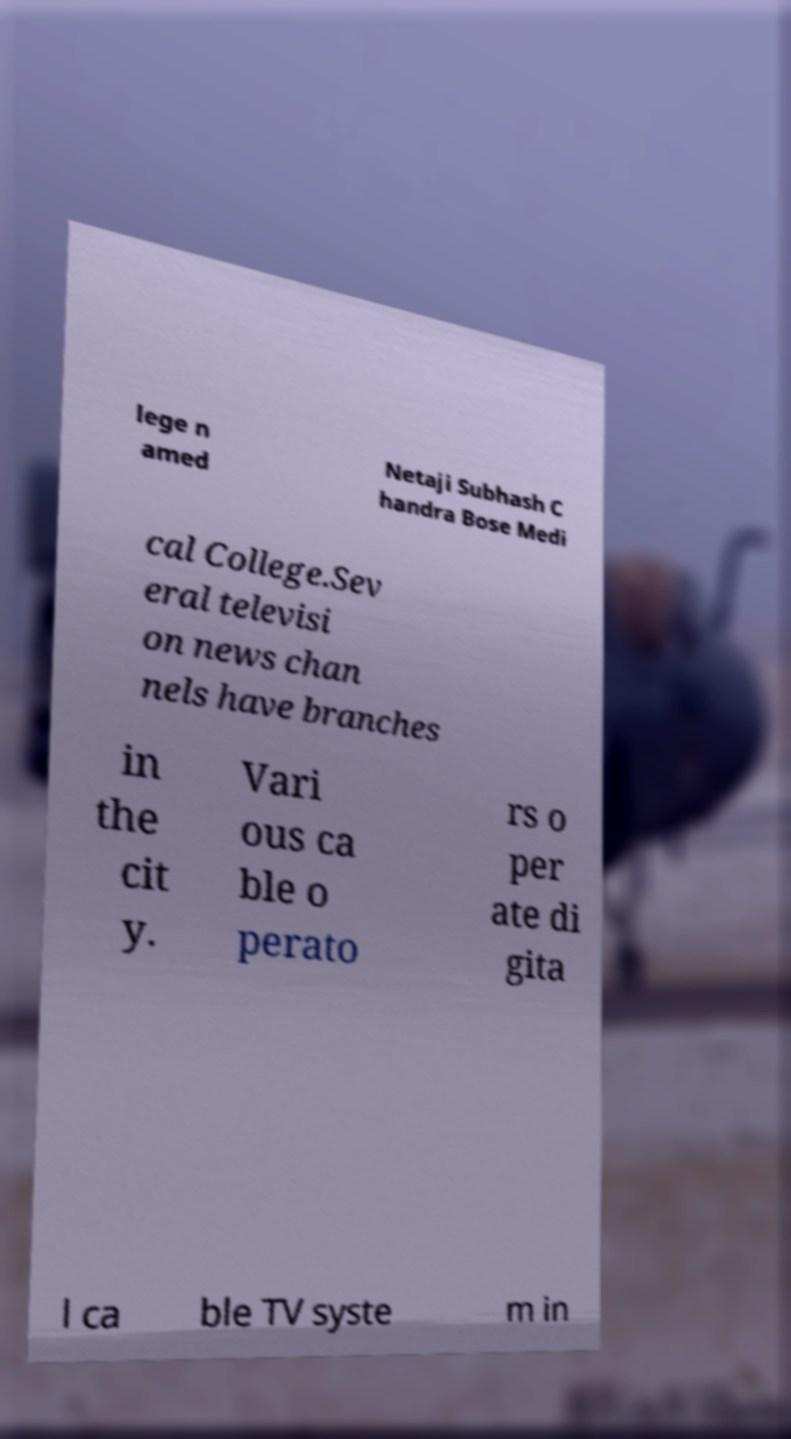Can you accurately transcribe the text from the provided image for me? lege n amed Netaji Subhash C handra Bose Medi cal College.Sev eral televisi on news chan nels have branches in the cit y. Vari ous ca ble o perato rs o per ate di gita l ca ble TV syste m in 